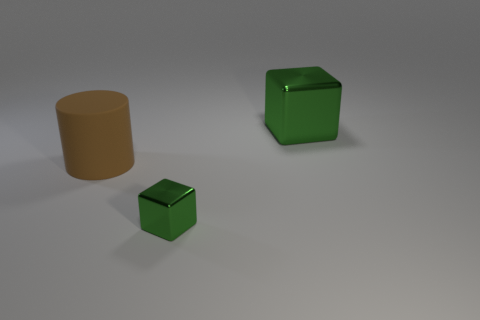Add 1 brown cylinders. How many objects exist? 4 Subtract all cubes. How many objects are left? 1 Add 1 brown rubber cylinders. How many brown rubber cylinders exist? 2 Subtract 0 yellow cubes. How many objects are left? 3 Subtract all small things. Subtract all large blue cylinders. How many objects are left? 2 Add 2 green things. How many green things are left? 4 